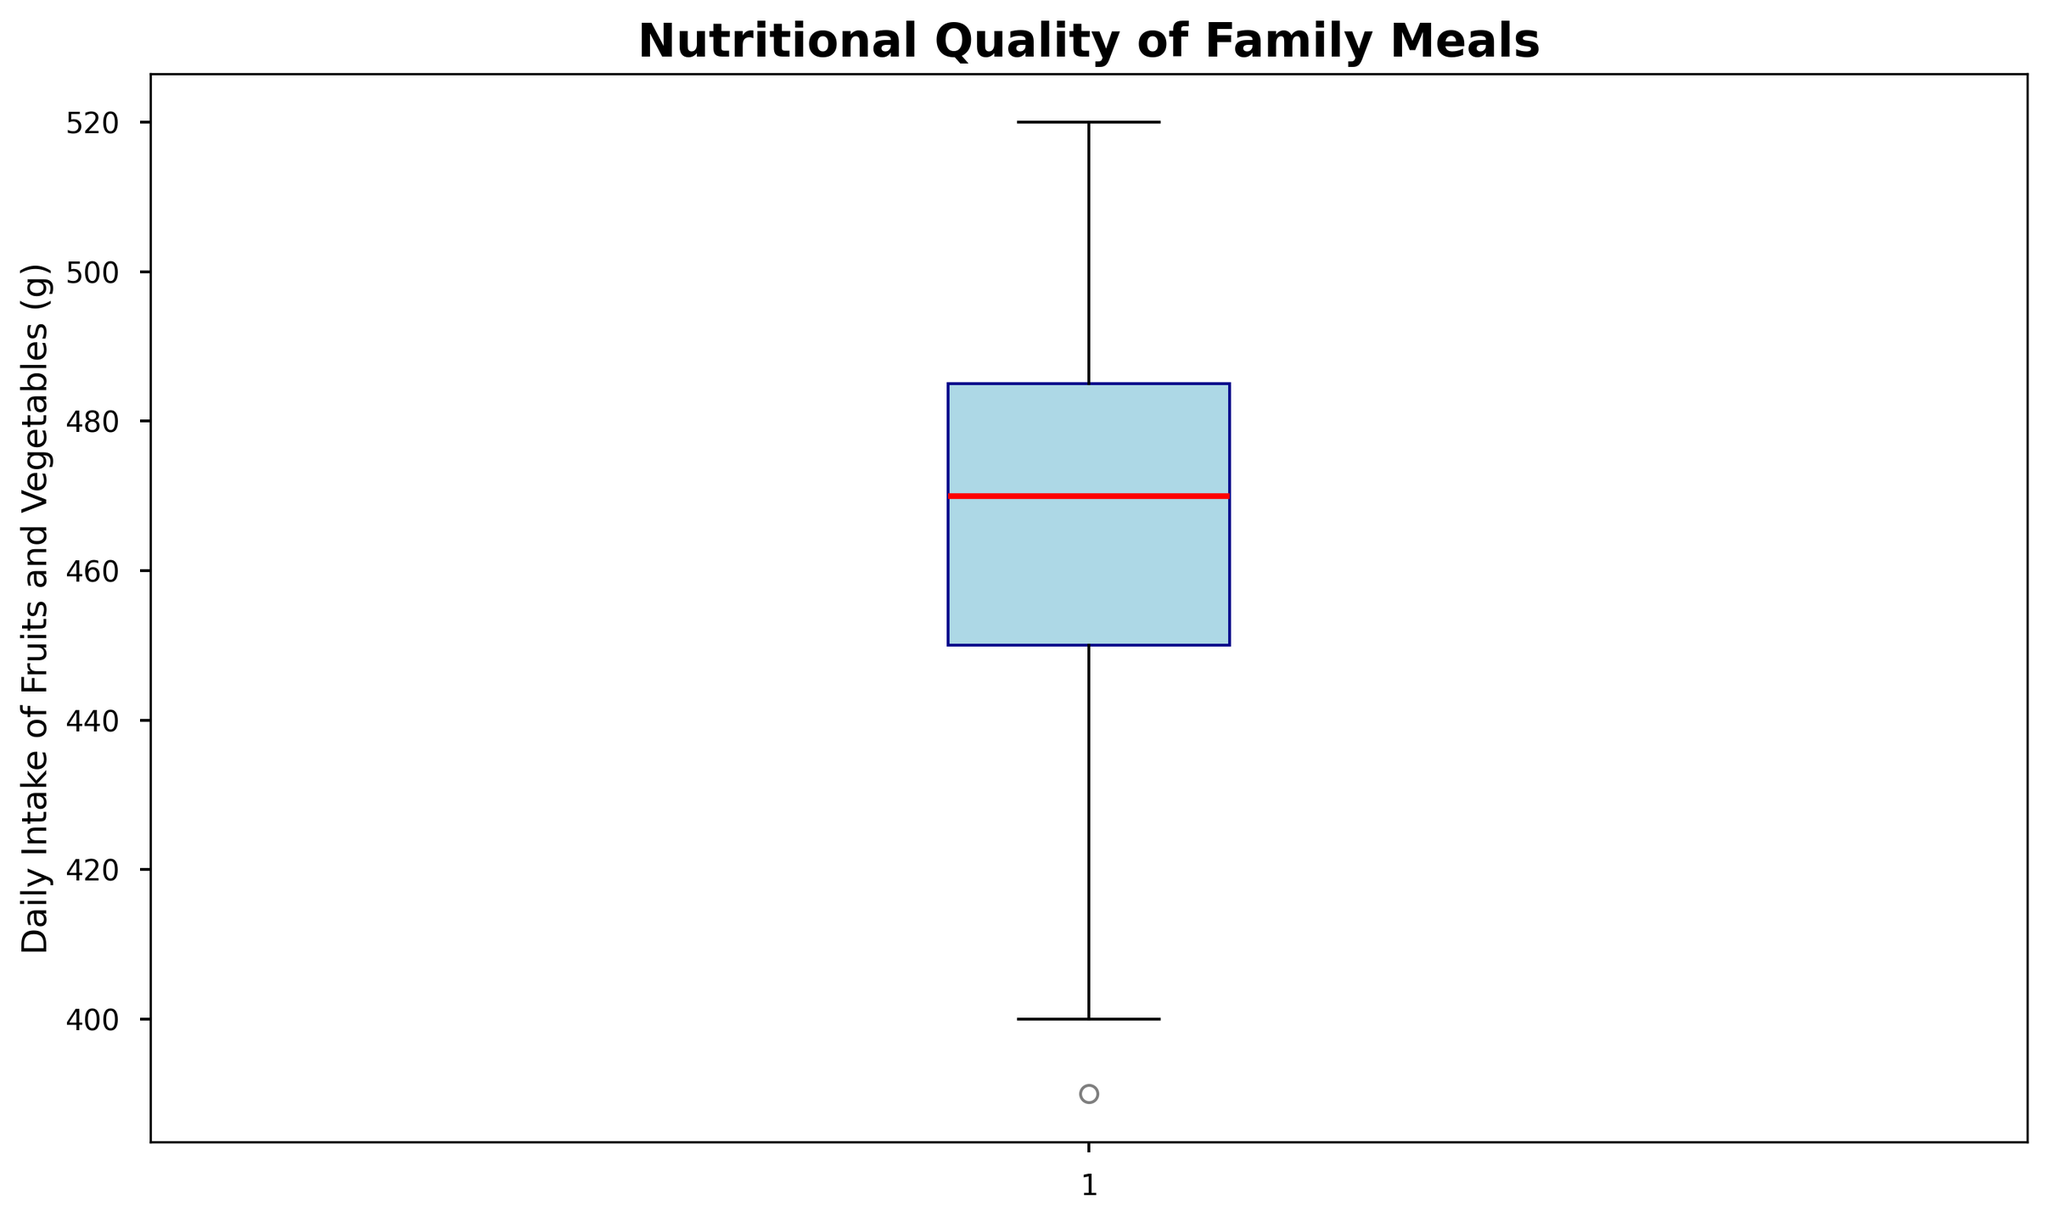What is the median daily intake of fruits and vegetables? The median value is denoted by a red line in the box plot.
Answer: 470g What is the range of the daily fruit and vegetable intake? The range is the difference between the maximum and minimum values in the dataset, as depicted by the whiskers.
Answer: 390g to 520g, so the range is 130g Which color represents the median value in the box plot? The median is represented by the red line within the box.
Answer: Red Is the daily intake of fruits and vegetables more often above or below 450g? Since the median is above 450g and the upper half contains more values closer to 470g, it indicates that the intake is more often above 450g.
Answer: Above 450g What is the interquartile range (IQR) of the daily intake of fruits and vegetables? IQR is the difference between the upper quartile (Q3) and lower quartile (Q1). These correspond to the edges of the box.
Answer: 460g to 495g, so the IQR is 35g Which family had the highest daily fruit and vegetable intake? The highest value in the dataset represents Family C at 520g, shown by the top whisker on the box plot.
Answer: Family C How many families have a daily intake of fruits and vegetables above 485g? Values above 485g lie within the upper whisker, counting the individual data points gives the number.
Answer: 10 families What is the most common range of daily fruit and vegetable intake among the families? The most common range corresponds to the height of the box, which reflects where the middle 50% of values fall.
Answer: 460g to 495g Is there more variability in the dataset below or above the median value? Variability can be visualized by comparing the length of the whiskers and box on either side of the median line. The upper whisker and box cover a slightly wider range.
Answer: Above the median What percentage of families consume at least 470g of fruits and vegetables daily? Calculate how many families have a daily intake of 470g or more and then compute that as a percentage of the total families.
Answer: 60% 